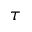Convert formula to latex. <formula><loc_0><loc_0><loc_500><loc_500>\tau</formula> 